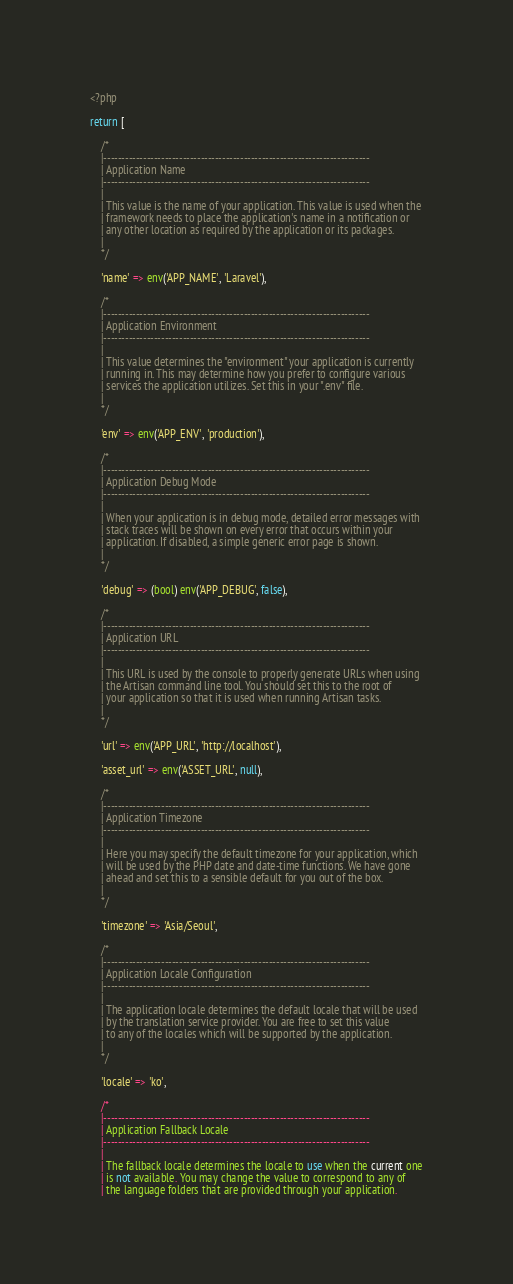Convert code to text. <code><loc_0><loc_0><loc_500><loc_500><_PHP_><?php

return [

    /*
    |--------------------------------------------------------------------------
    | Application Name
    |--------------------------------------------------------------------------
    |
    | This value is the name of your application. This value is used when the
    | framework needs to place the application's name in a notification or
    | any other location as required by the application or its packages.
    |
    */

    'name' => env('APP_NAME', 'Laravel'),

    /*
    |--------------------------------------------------------------------------
    | Application Environment
    |--------------------------------------------------------------------------
    |
    | This value determines the "environment" your application is currently
    | running in. This may determine how you prefer to configure various
    | services the application utilizes. Set this in your ".env" file.
    |
    */

    'env' => env('APP_ENV', 'production'),

    /*
    |--------------------------------------------------------------------------
    | Application Debug Mode
    |--------------------------------------------------------------------------
    |
    | When your application is in debug mode, detailed error messages with
    | stack traces will be shown on every error that occurs within your
    | application. If disabled, a simple generic error page is shown.
    |
    */

    'debug' => (bool) env('APP_DEBUG', false),

    /*
    |--------------------------------------------------------------------------
    | Application URL
    |--------------------------------------------------------------------------
    |
    | This URL is used by the console to properly generate URLs when using
    | the Artisan command line tool. You should set this to the root of
    | your application so that it is used when running Artisan tasks.
    |
    */

    'url' => env('APP_URL', 'http://localhost'),

    'asset_url' => env('ASSET_URL', null),

    /*
    |--------------------------------------------------------------------------
    | Application Timezone
    |--------------------------------------------------------------------------
    |
    | Here you may specify the default timezone for your application, which
    | will be used by the PHP date and date-time functions. We have gone
    | ahead and set this to a sensible default for you out of the box.
    |
    */

    'timezone' => 'Asia/Seoul',

    /*
    |--------------------------------------------------------------------------
    | Application Locale Configuration
    |--------------------------------------------------------------------------
    |
    | The application locale determines the default locale that will be used
    | by the translation service provider. You are free to set this value
    | to any of the locales which will be supported by the application.
    |
    */

    'locale' => 'ko',

    /*
    |--------------------------------------------------------------------------
    | Application Fallback Locale
    |--------------------------------------------------------------------------
    |
    | The fallback locale determines the locale to use when the current one
    | is not available. You may change the value to correspond to any of
    | the language folders that are provided through your application.</code> 